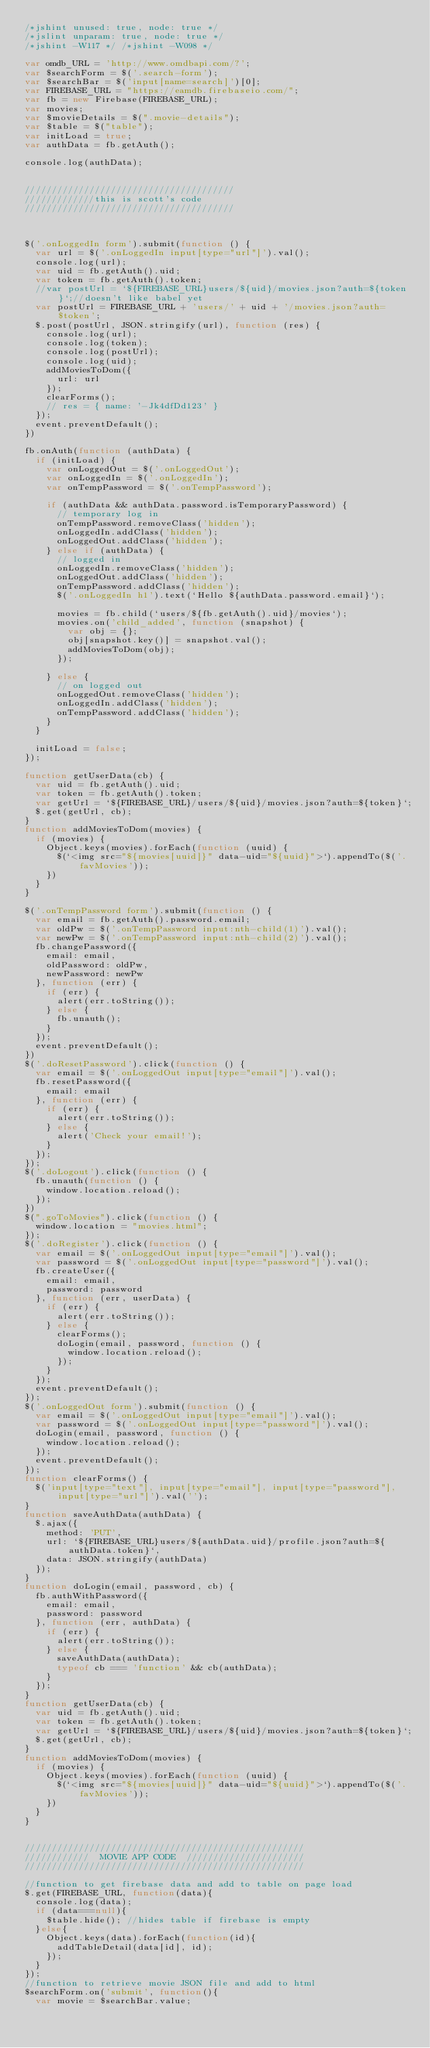Convert code to text. <code><loc_0><loc_0><loc_500><loc_500><_JavaScript_>/*jshint unused: true, node: true */
/*jslint unparam: true, node: true */
/*jshint -W117 */ /*jshint -W098 */

var omdb_URL = 'http://www.omdbapi.com/?';
var $searchForm = $('.search-form');
var $searchBar = $('input[name=search]')[0];
var FIREBASE_URL = "https://eamdb.firebaseio.com/";
var fb = new Firebase(FIREBASE_URL);
var movies;
var $movieDetails = $(".movie-details");
var $table = $("table");
var initLoad = true;
var authData = fb.getAuth();

console.log(authData);


///////////////////////////////////////
/////////////this is scott's code
///////////////////////////////////////



$('.onLoggedIn form').submit(function () {
  var url = $('.onLoggedIn input[type="url"]').val();
  console.log(url);
  var uid = fb.getAuth().uid;
  var token = fb.getAuth().token;
  //var postUrl = `${FIREBASE_URL}users/${uid}/movies.json?auth=${token}`;//doesn't like babel yet
  var postUrl = FIREBASE_URL + 'users/' + uid + '/movies.json?auth=$token';
  $.post(postUrl, JSON.stringify(url), function (res) {
    console.log(url);
    console.log(token);
    console.log(postUrl);
    console.log(uid);
    addMoviesToDom({
      url: url
    });
    clearForms();
    // res = { name: '-Jk4dfDd123' }
  });
  event.preventDefault();
})

fb.onAuth(function (authData) {
  if (initLoad) {
    var onLoggedOut = $('.onLoggedOut');
    var onLoggedIn = $('.onLoggedIn');
    var onTempPassword = $('.onTempPassword');

    if (authData && authData.password.isTemporaryPassword) {
      // temporary log in
      onTempPassword.removeClass('hidden');
      onLoggedIn.addClass('hidden');
      onLoggedOut.addClass('hidden');
    } else if (authData) {
      // logged in
      onLoggedIn.removeClass('hidden');
      onLoggedOut.addClass('hidden');
      onTempPassword.addClass('hidden');
      $('.onLoggedIn h1').text(`Hello ${authData.password.email}`);

      movies = fb.child(`users/${fb.getAuth().uid}/movies`);
      movies.on('child_added', function (snapshot) {
        var obj = {};
        obj[snapshot.key()] = snapshot.val();
        addMoviesToDom(obj);
      });

    } else {
      // on logged out
      onLoggedOut.removeClass('hidden');
      onLoggedIn.addClass('hidden');
      onTempPassword.addClass('hidden');
    }
  }

  initLoad = false;
});

function getUserData(cb) {
  var uid = fb.getAuth().uid;
  var token = fb.getAuth().token;
  var getUrl = `${FIREBASE_URL}/users/${uid}/movies.json?auth=${token}`;
  $.get(getUrl, cb);
}
function addMoviesToDom(movies) {
  if (movies) {
    Object.keys(movies).forEach(function (uuid) {
      $(`<img src="${movies[uuid]}" data-uid="${uuid}">`).appendTo($('.favMovies'));
    })
  }
}

$('.onTempPassword form').submit(function () {
  var email = fb.getAuth().password.email;
  var oldPw = $('.onTempPassword input:nth-child(1)').val();
  var newPw = $('.onTempPassword input:nth-child(2)').val();
  fb.changePassword({
    email: email,
    oldPassword: oldPw,
    newPassword: newPw
  }, function (err) {
    if (err) {
      alert(err.toString());
    } else {
      fb.unauth();
    }
  });
  event.preventDefault();
})
$('.doResetPassword').click(function () {
  var email = $('.onLoggedOut input[type="email"]').val();
  fb.resetPassword({
    email: email
  }, function (err) {
    if (err) {
      alert(err.toString());
    } else {
      alert('Check your email!');
    }
  });
});
$('.doLogout').click(function () {
  fb.unauth(function () {
    window.location.reload();
  });
})
$(".goToMovies").click(function () {
  window.location = "movies.html";
});
$('.doRegister').click(function () {
  var email = $('.onLoggedOut input[type="email"]').val();
  var password = $('.onLoggedOut input[type="password"]').val();
  fb.createUser({
    email: email,
    password: password
  }, function (err, userData) {
    if (err) {
      alert(err.toString());
    } else {
      clearForms();
      doLogin(email, password, function () {
        window.location.reload();
      });
    }
  });
  event.preventDefault();
});
$('.onLoggedOut form').submit(function () {
  var email = $('.onLoggedOut input[type="email"]').val();
  var password = $('.onLoggedOut input[type="password"]').val();
  doLogin(email, password, function () {
    window.location.reload();
  });
  event.preventDefault();
});
function clearForms() {
  $('input[type="text"], input[type="email"], input[type="password"], input[type="url"]').val('');
}
function saveAuthData(authData) {
  $.ajax({
    method: 'PUT',
    url: `${FIREBASE_URL}users/${authData.uid}/profile.json?auth=${authData.token}`,
    data: JSON.stringify(authData)
  });
}
function doLogin(email, password, cb) {
  fb.authWithPassword({
    email: email,
    password: password
  }, function (err, authData) {
    if (err) {
      alert(err.toString());
    } else {
      saveAuthData(authData);
      typeof cb === 'function' && cb(authData);
    }
  });
}
function getUserData(cb) {
  var uid = fb.getAuth().uid;
  var token = fb.getAuth().token;
  var getUrl = `${FIREBASE_URL}/users/${uid}/movies.json?auth=${token}`;
  $.get(getUrl, cb);
}
function addMoviesToDom(movies) {
  if (movies) {
    Object.keys(movies).forEach(function (uuid) {
      $(`<img src="${movies[uuid]}" data-uid="${uuid}">`).appendTo($('.favMovies'));
    })
  }
}


////////////////////////////////////////////////////
////////////  MOVIE APP CODE  //////////////////////
////////////////////////////////////////////////////

//function to get firebase data and add to table on page load
$.get(FIREBASE_URL, function(data){
  console.log(data);
  if (data===null){
    $table.hide(); //hides table if firebase is empty
  }else{
    Object.keys(data).forEach(function(id){
      addTableDetail(data[id], id);
    });
  }
});
//function to retrieve movie JSON file and add to html
$searchForm.on('submit', function(){
  var movie = $searchBar.value;</code> 